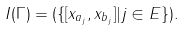Convert formula to latex. <formula><loc_0><loc_0><loc_500><loc_500>I ( \Gamma ) = ( \{ [ x _ { a _ { j } } , x _ { b _ { j } } ] | j \in E \} ) .</formula> 